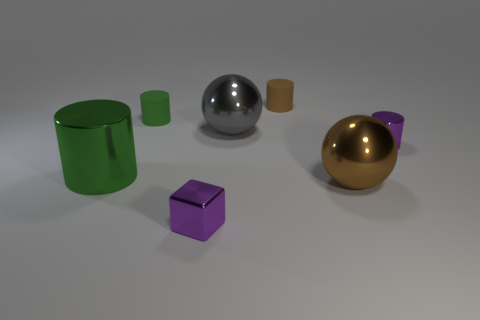Add 1 big metal cylinders. How many objects exist? 8 Subtract all spheres. How many objects are left? 5 Add 7 matte cylinders. How many matte cylinders exist? 9 Subtract 2 green cylinders. How many objects are left? 5 Subtract all big red metal cubes. Subtract all large metal objects. How many objects are left? 4 Add 7 purple metallic cylinders. How many purple metallic cylinders are left? 8 